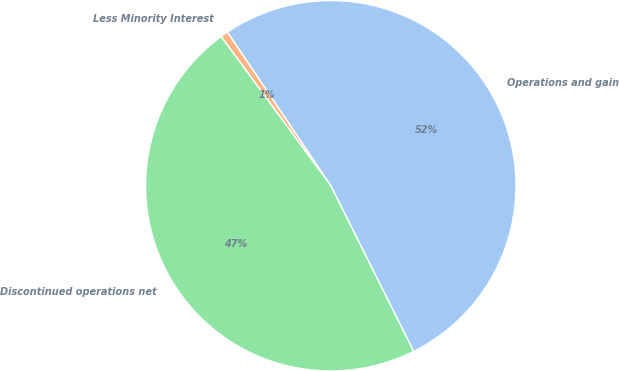<chart> <loc_0><loc_0><loc_500><loc_500><pie_chart><fcel>Operations and gain<fcel>Less Minority Interest<fcel>Discontinued operations net<nl><fcel>52.04%<fcel>0.66%<fcel>47.3%<nl></chart> 